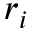Convert formula to latex. <formula><loc_0><loc_0><loc_500><loc_500>r _ { i }</formula> 